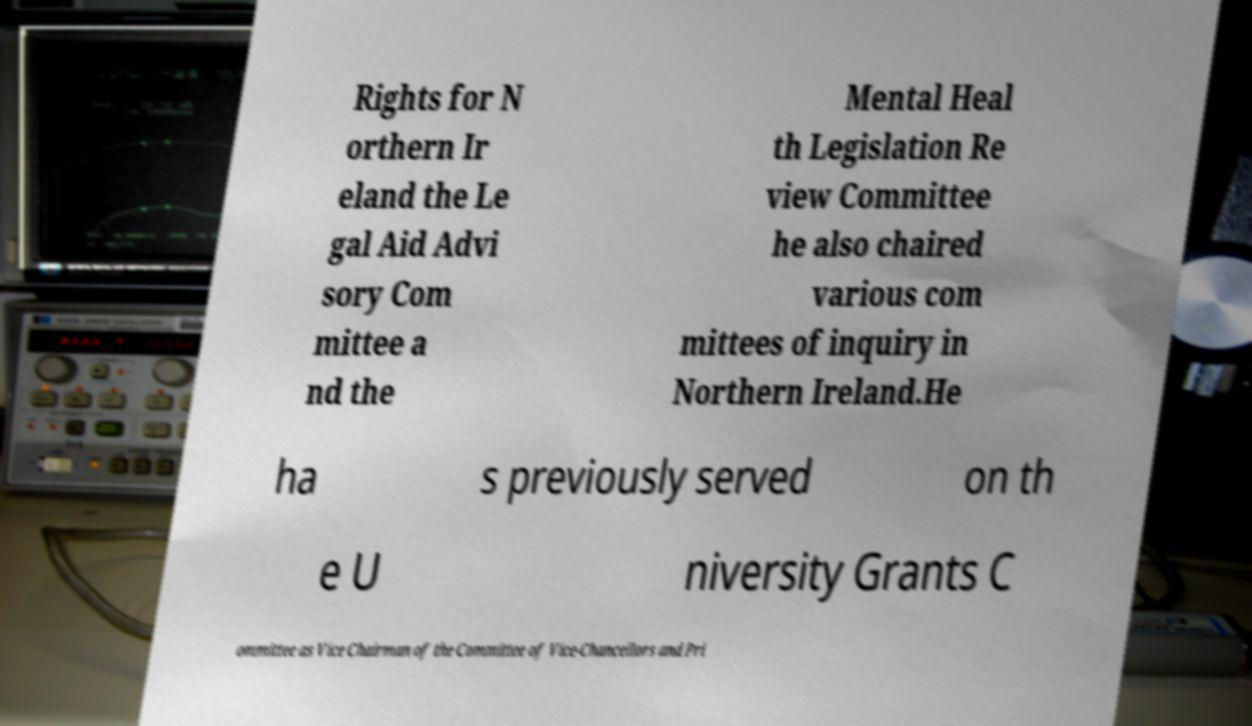Could you assist in decoding the text presented in this image and type it out clearly? Rights for N orthern Ir eland the Le gal Aid Advi sory Com mittee a nd the Mental Heal th Legislation Re view Committee he also chaired various com mittees of inquiry in Northern Ireland.He ha s previously served on th e U niversity Grants C ommittee as Vice Chairman of the Committee of Vice-Chancellors and Pri 